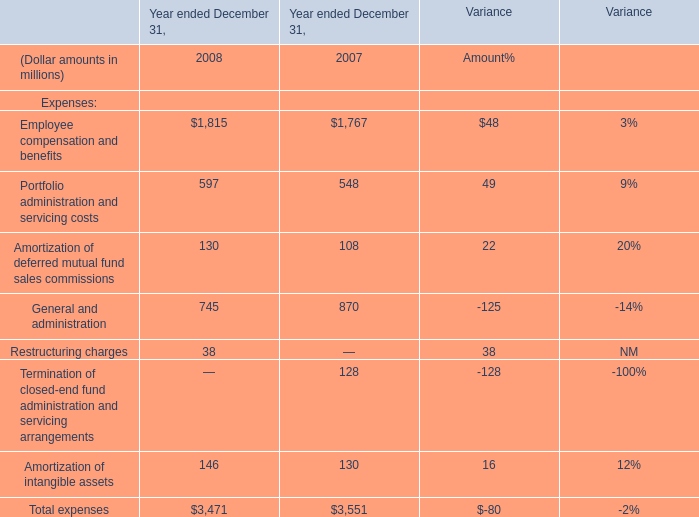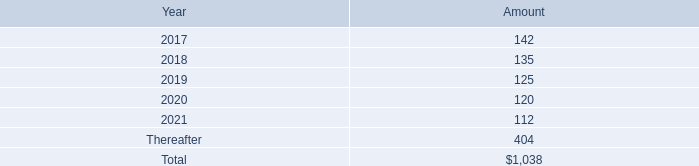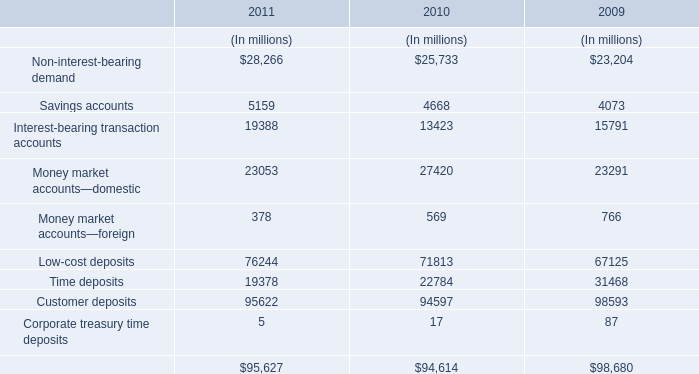what are the various capital commitments to fund sponsored investment funds as a percentage of the total future minimum commitments under the operating leases? 
Computations: (192 / 1038)
Answer: 0.18497. 